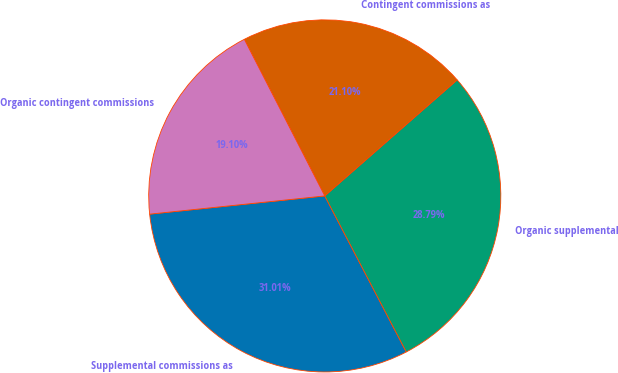Convert chart to OTSL. <chart><loc_0><loc_0><loc_500><loc_500><pie_chart><fcel>Supplemental commissions as<fcel>Organic supplemental<fcel>Contingent commissions as<fcel>Organic contingent commissions<nl><fcel>31.01%<fcel>28.79%<fcel>21.1%<fcel>19.1%<nl></chart> 